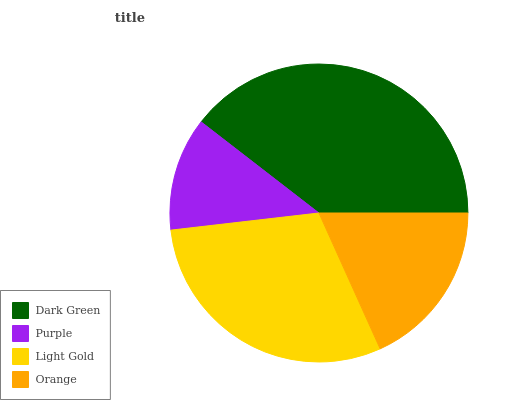Is Purple the minimum?
Answer yes or no. Yes. Is Dark Green the maximum?
Answer yes or no. Yes. Is Light Gold the minimum?
Answer yes or no. No. Is Light Gold the maximum?
Answer yes or no. No. Is Light Gold greater than Purple?
Answer yes or no. Yes. Is Purple less than Light Gold?
Answer yes or no. Yes. Is Purple greater than Light Gold?
Answer yes or no. No. Is Light Gold less than Purple?
Answer yes or no. No. Is Light Gold the high median?
Answer yes or no. Yes. Is Orange the low median?
Answer yes or no. Yes. Is Dark Green the high median?
Answer yes or no. No. Is Purple the low median?
Answer yes or no. No. 